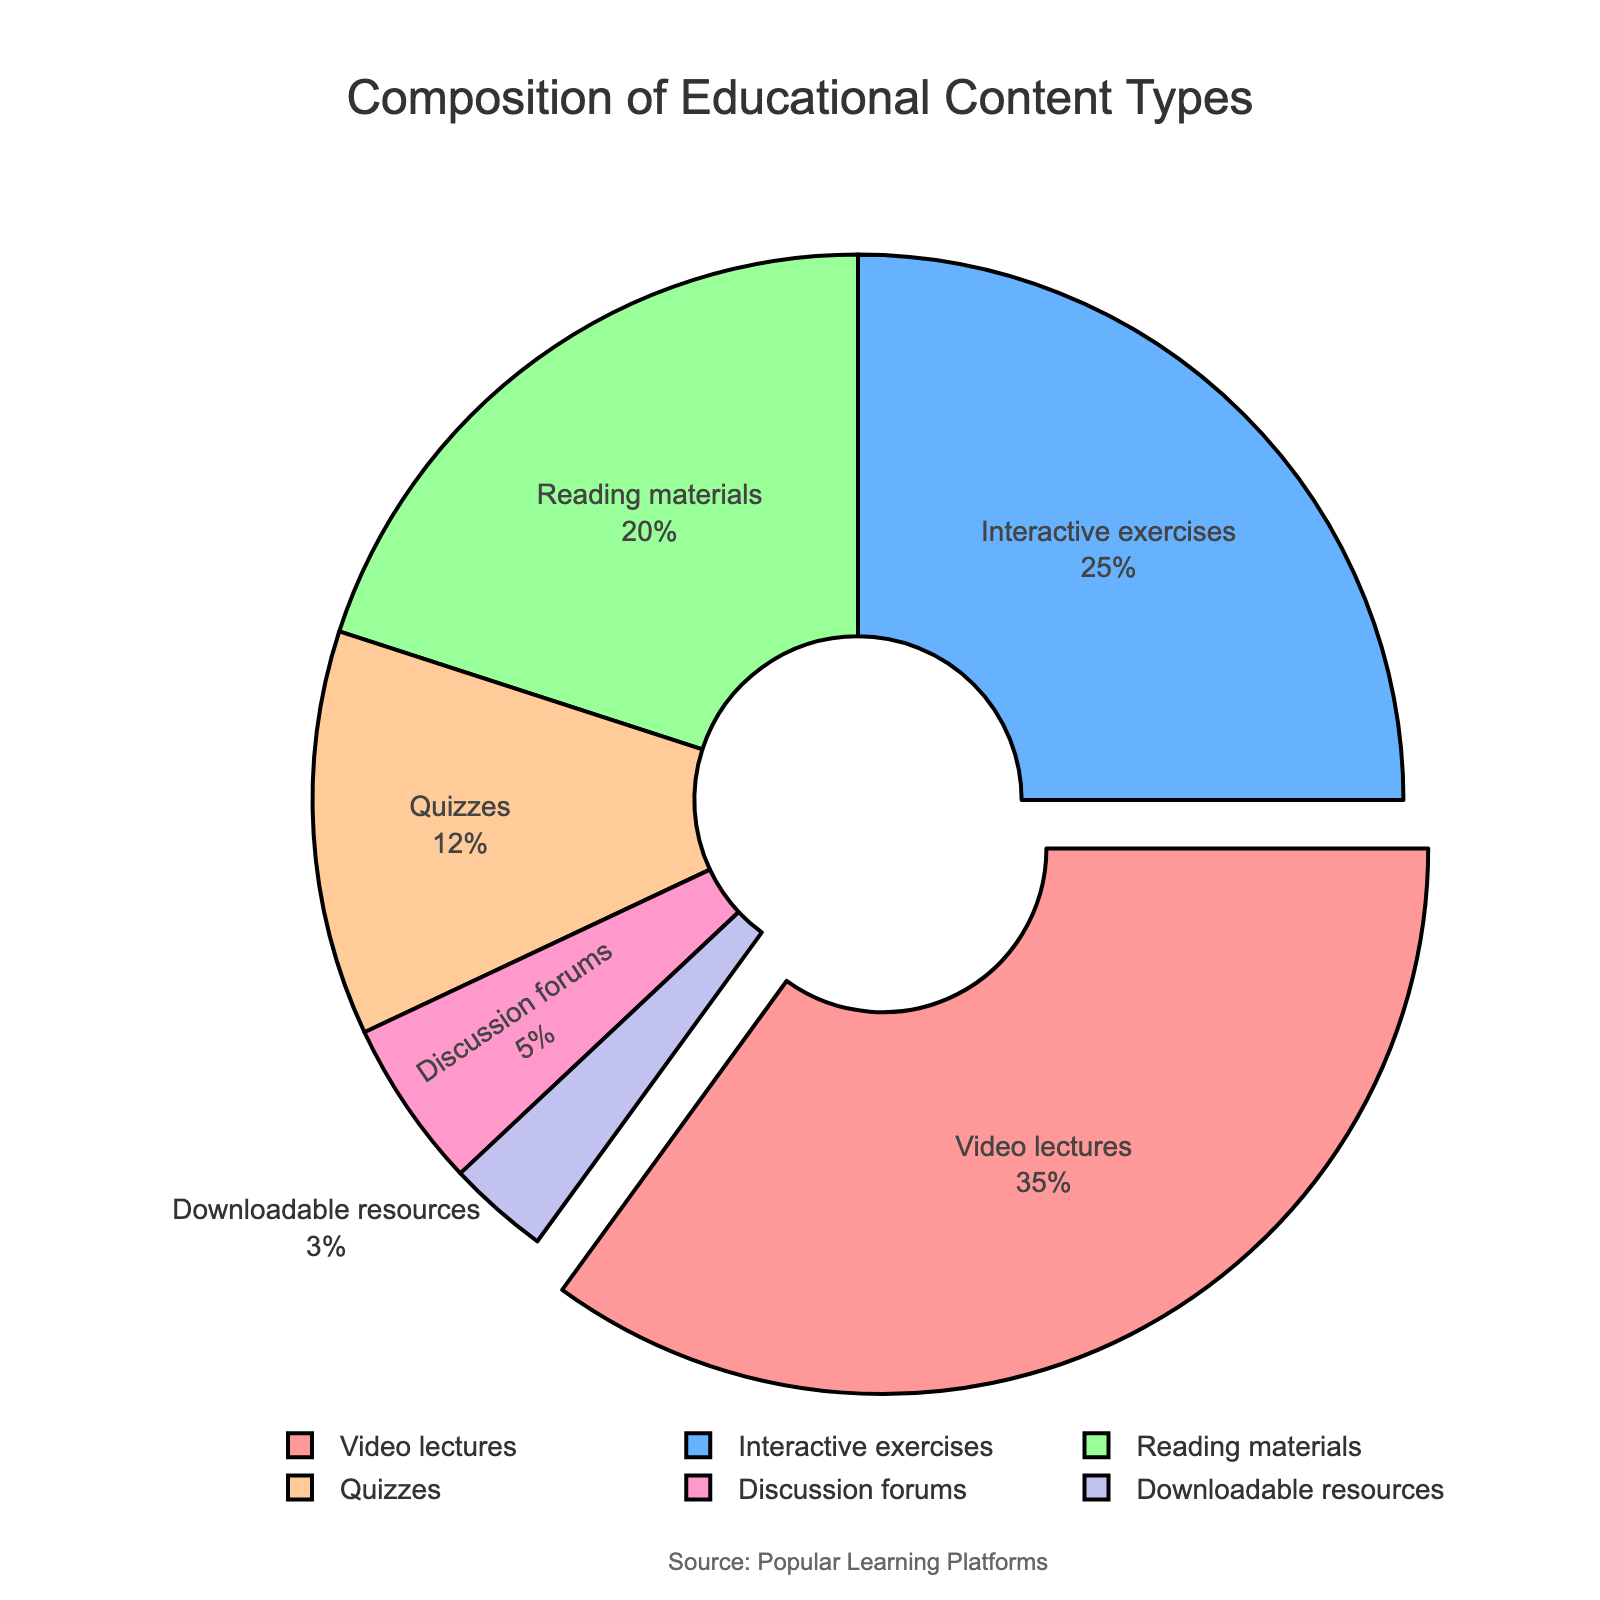What is the most common type of educational content in popular learning platforms? Video lectures are the most common type of educational content, as indicated by the largest segment of the pie chart.
Answer: Video lectures Which content type has the smallest proportion? The smallest segment of the pie chart belongs to "Downloadable resources", which is color-coded and represents the smallest percentage.
Answer: Downloadable resources What is the combined percentage of Interactive exercises and Reading materials? Interactive exercises have 25% and Reading materials have 20%. Their combined percentage is 25% + 20% = 45%.
Answer: 45% Is the percentage of Quizzes higher or lower than Discussion forums? Quizzes have 12% while Discussion forums have 5%. Since 12% is greater than 5%, Quizzes have a higher percentage than Discussion forums.
Answer: Higher What segment's color is represented by pink shades? The pink-colored segment represents "Video lectures."
Answer: Video lectures How much more percentage do Video lectures have compared to Discussion forums? Video lectures have 35% and Discussion forums have 5%. The difference is 35% - 5% = 30%.
Answer: 30% Which content type is pulled out from the pie chart, and why? The pie chart pulls out "Video lectures" because it represents the maximum percentage value.
Answer: Video lectures What is the percentage difference between Reading materials and Quizzes? Reading materials hold 20% while Quizzes hold 12%. The percentage difference is 20% - 12% = 8%.
Answer: 8% How does the percentage of Interactive exercises compare to the combined percentage of Quizzes and Downloadable resources? Interactive exercises represent 25%, Quizzes are 12%, and Downloadable resources are 3%. Combining Quizzes and Downloadable resources gives 12% + 3% = 15%. Therefore, Interactive exercises (25%) have a 10% higher proportion.
Answer: Higher by 10% What does the chart’s title tell you about the data? The title of the chart is "Composition of Educational Content Types," indicating that the data represents how different types of content are distributed in popular learning platforms.
Answer: Composition of Educational Content Types 